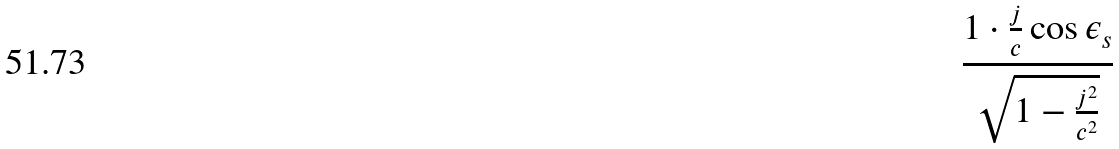Convert formula to latex. <formula><loc_0><loc_0><loc_500><loc_500>\frac { 1 \cdot \frac { j } { c } \cos \epsilon _ { s } } { \sqrt { 1 - \frac { j ^ { 2 } } { c ^ { 2 } } } }</formula> 